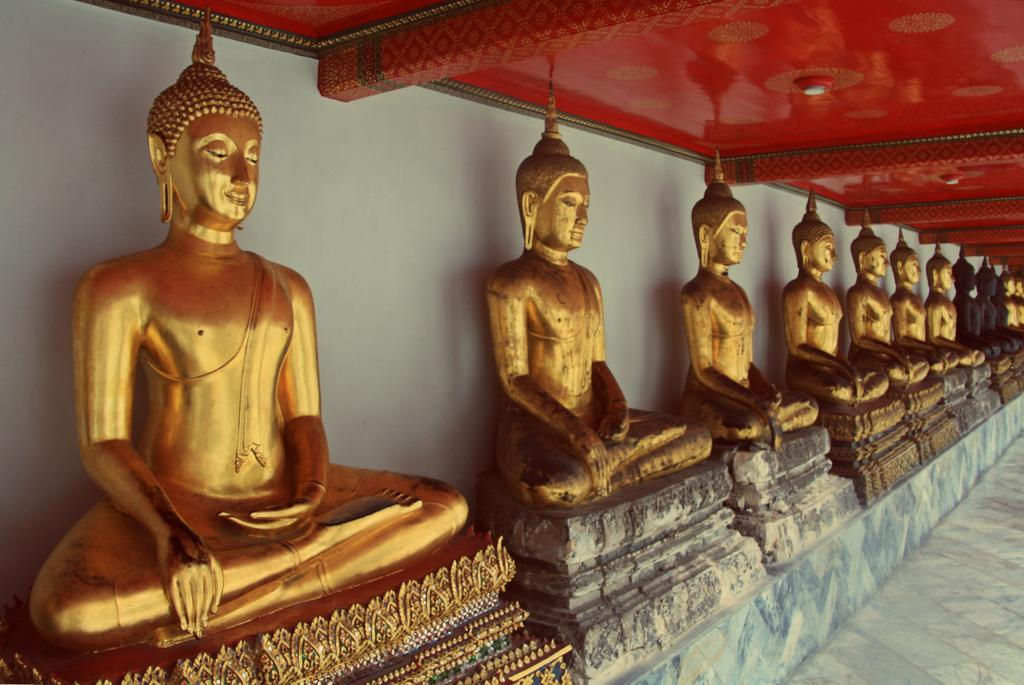What type of statues can be seen in the image? There are Buddha statues in the image. Can you describe the color of some of the statues? Some of the statues are in black color, while others are in golden color. Are all the statues the same color? No, the statues have different colors, with some being black and others being golden. Is there an airplane visible in the image? No, there is no airplane present in the image; it only features Buddha statues in different colors. 